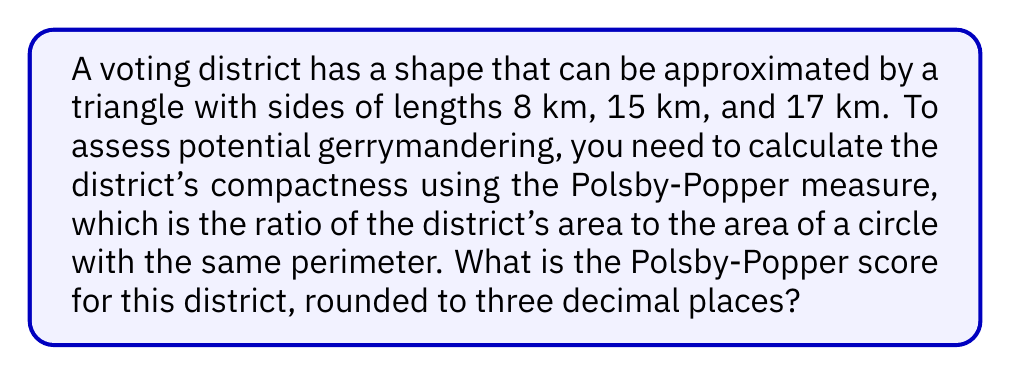Teach me how to tackle this problem. Let's approach this step-by-step:

1) First, we need to calculate the perimeter of the triangle:
   $P = 8 + 15 + 17 = 40$ km

2) Now, we need to find the area of the triangle. We can use Heron's formula:
   $A = \sqrt{s(s-a)(s-b)(s-c)}$
   where $s$ is the semi-perimeter: $s = \frac{a+b+c}{2} = \frac{40}{2} = 20$

3) Plugging into Heron's formula:
   $A = \sqrt{20(20-8)(20-15)(20-17)}$
   $= \sqrt{20 \cdot 12 \cdot 5 \cdot 3}$
   $= \sqrt{3600} = 60$ km²

4) The Polsby-Popper measure is given by:
   $PP = \frac{4\pi A}{P^2}$

5) Substituting our values:
   $PP = \frac{4\pi \cdot 60}{40^2} = \frac{240\pi}{1600} = 0.4712389$

6) Rounding to three decimal places:
   $PP \approx 0.471$
Answer: 0.471 